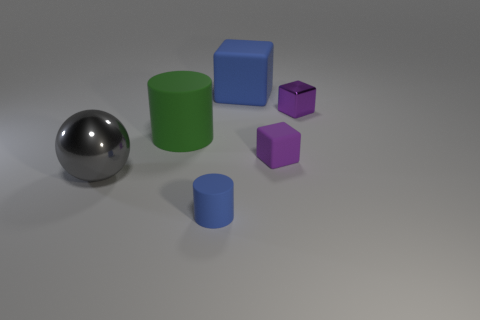Can you tell me what colors the objects in this image have? Certainly! In the image, there is a large metallic ball that appears silver or gray. Then, there is a big green cylinder and a large blue cube. In addition, there are two small cylinders, one blue and one green, and two tiny purple cubes. 